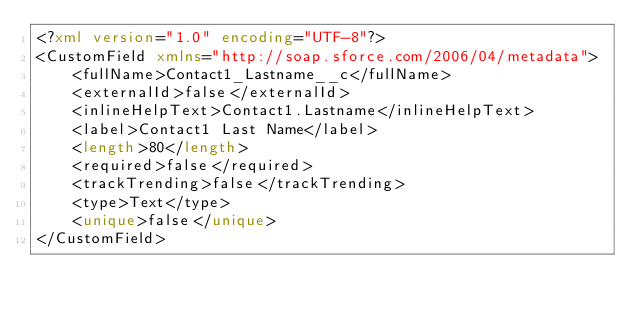Convert code to text. <code><loc_0><loc_0><loc_500><loc_500><_XML_><?xml version="1.0" encoding="UTF-8"?>
<CustomField xmlns="http://soap.sforce.com/2006/04/metadata">
    <fullName>Contact1_Lastname__c</fullName>
    <externalId>false</externalId>
    <inlineHelpText>Contact1.Lastname</inlineHelpText>
    <label>Contact1 Last Name</label>
    <length>80</length>
    <required>false</required>
    <trackTrending>false</trackTrending>
    <type>Text</type>
    <unique>false</unique>
</CustomField>
</code> 